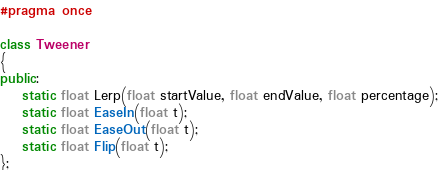Convert code to text. <code><loc_0><loc_0><loc_500><loc_500><_C++_>#pragma once

class Tweener
{
public:
	static float Lerp(float startValue, float endValue, float percentage);
	static float EaseIn(float t);
	static float EaseOut(float t);
	static float Flip(float t);
};</code> 